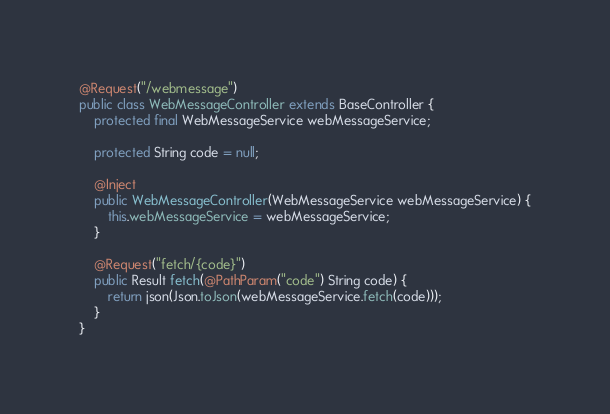Convert code to text. <code><loc_0><loc_0><loc_500><loc_500><_Java_>@Request("/webmessage")
public class WebMessageController extends BaseController {
    protected final WebMessageService webMessageService;

    protected String code = null;

    @Inject
    public WebMessageController(WebMessageService webMessageService) {
        this.webMessageService = webMessageService;
    }

    @Request("fetch/{code}")
    public Result fetch(@PathParam("code") String code) {
        return json(Json.toJson(webMessageService.fetch(code)));
    }
}
</code> 